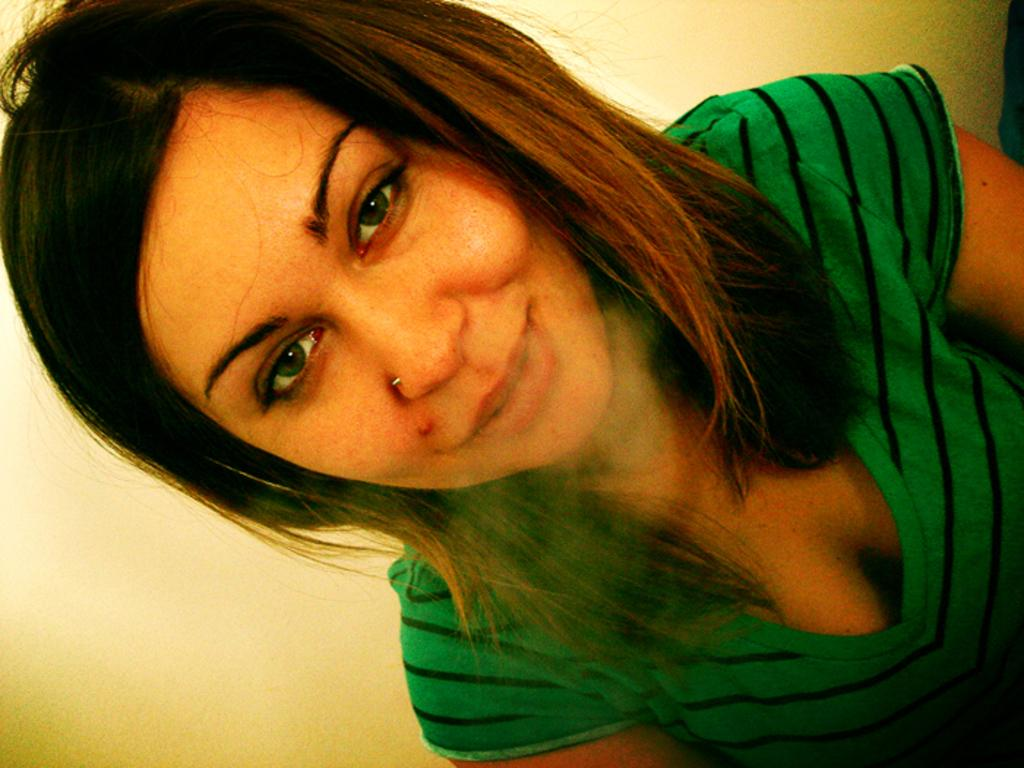Who is the main subject in the image? There is a lady in the center of the image. What type of property does the lady own in the image? There is no information about the lady owning any property in the image. What kind of flesh can be seen on the lady's body in the image? There is no information about the lady's body or any flesh visible in the image. 